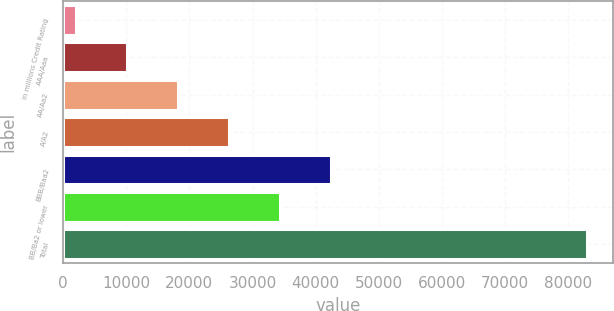<chart> <loc_0><loc_0><loc_500><loc_500><bar_chart><fcel>in millions Credit Rating<fcel>AAA/Aaa<fcel>AA/Aa2<fcel>A/A2<fcel>BBB/Baa2<fcel>BB/Ba2 or lower<fcel>Total<nl><fcel>2012<fcel>10101.2<fcel>18190.4<fcel>26279.6<fcel>42458<fcel>34368.8<fcel>82904<nl></chart> 